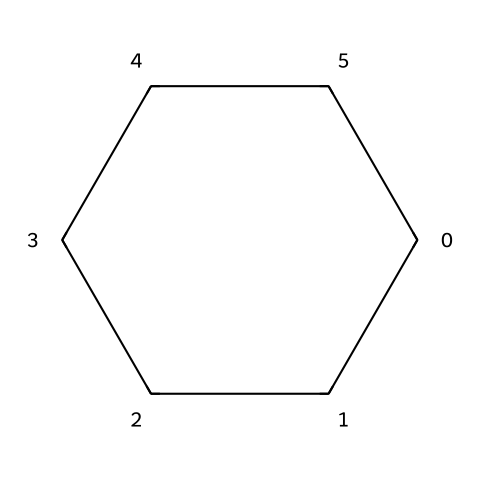What is the molecular formula of this compound? The compound is cyclohexane, which consists of 6 carbon atoms and 12 hydrogen atoms. This can be deduced from the SMILES notation where 'C' represents carbon and the presence of hydrogen is implied by the tetravalency of carbon and no explicit hydrogens being shown. Thus, the molecular formula is C6H12.
Answer: C6H12 How many carbon atoms are in this structure? The SMILES notation indicates "C1CCCCC1", which shows 6 carbon atoms forming a ring. The "1" denotes a cyclic structure, confirming that all 6 carbons are part of a single cycle.
Answer: 6 What type of bonding is present in this molecule? The molecule has single covalent bonds which can be inferred as all connections are represented by single 'C' symbols indicating sigma bonds only, and the lack of double or triple bond notations.
Answer: single covalent bonds What is the angle between the carbon atoms in this structure? In cyclohexane, the bond angles are approximately 109.5 degrees due to its tetrahedral geometry around each carbon atom. The ring structure forces this angle to be slightly altered from the typical tetrahedral angle, but it remains close to 109.5 degrees.
Answer: 109.5 degrees What type of hydrocarbon is cyclohexane classified as? Cyclohexane is classified as a saturated hydrocarbon because all carbon-carbon bonds are single bonds, and it is fully saturated with hydrogen atoms without any available pi bonds or unsaturation.
Answer: saturated hydrocarbon Is cyclohexane a polar or nonpolar solvent? Cyclohexane is a nonpolar solvent due to its symmetrical structure and lack of electronegative atoms that would create a permanent dipole moment; as a result, it does not mix with water and is generally used for nonpolar solute extraction.
Answer: nonpolar solvent 